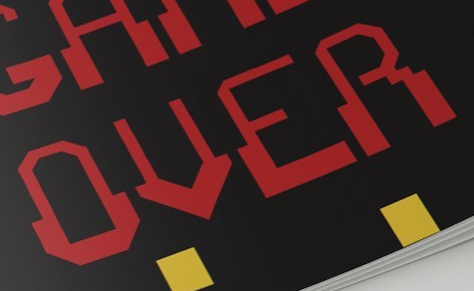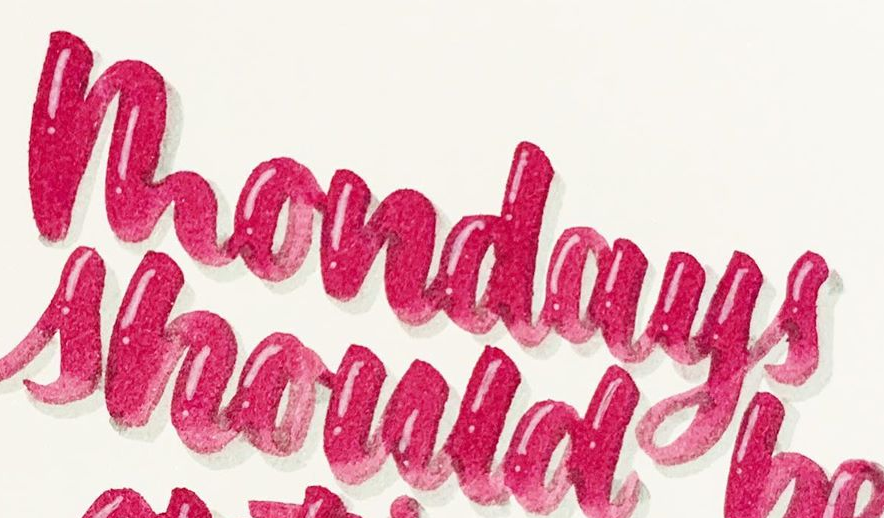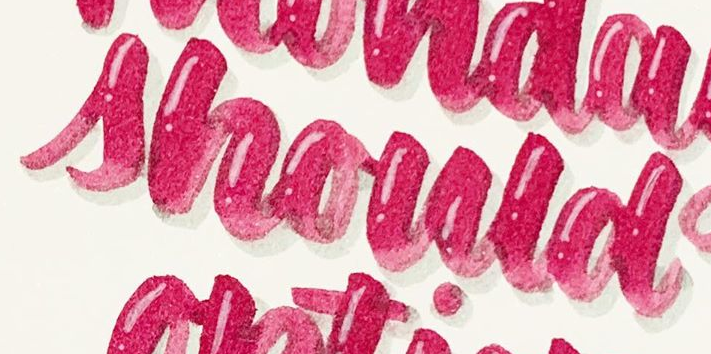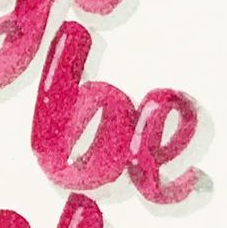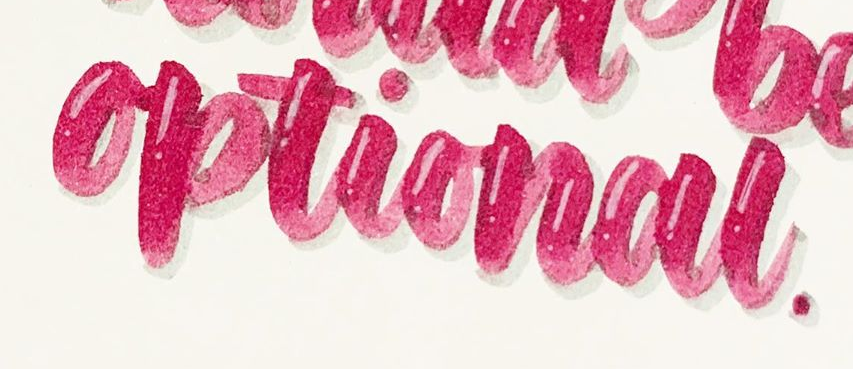What words can you see in these images in sequence, separated by a semicolon? OVER; mondays; should; be; optional 